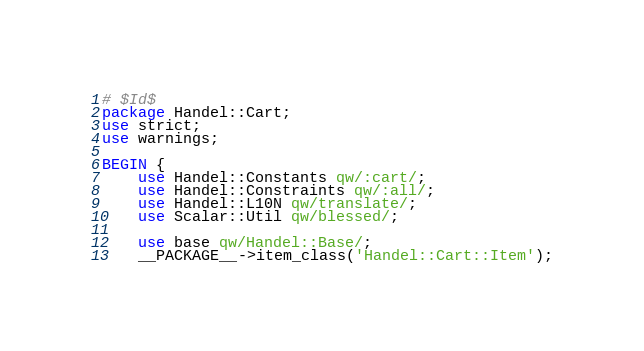Convert code to text. <code><loc_0><loc_0><loc_500><loc_500><_Perl_># $Id$
package Handel::Cart;
use strict;
use warnings;

BEGIN {
    use Handel::Constants qw/:cart/;
    use Handel::Constraints qw/:all/;
    use Handel::L10N qw/translate/;
    use Scalar::Util qw/blessed/;

    use base qw/Handel::Base/;
    __PACKAGE__->item_class('Handel::Cart::Item');</code> 